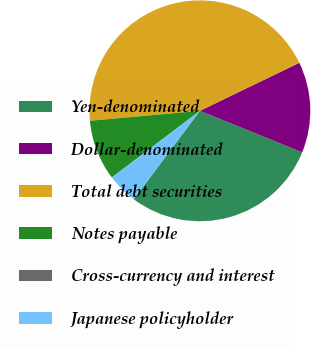<chart> <loc_0><loc_0><loc_500><loc_500><pie_chart><fcel>Yen-denominated<fcel>Dollar-denominated<fcel>Total debt securities<fcel>Notes payable<fcel>Cross-currency and interest<fcel>Japanese policyholder<nl><fcel>29.08%<fcel>13.3%<fcel>44.27%<fcel>8.87%<fcel>0.02%<fcel>4.45%<nl></chart> 